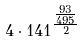Convert formula to latex. <formula><loc_0><loc_0><loc_500><loc_500>4 \cdot 1 4 1 ^ { \frac { \frac { 9 3 } { 4 9 5 } } { 2 } }</formula> 